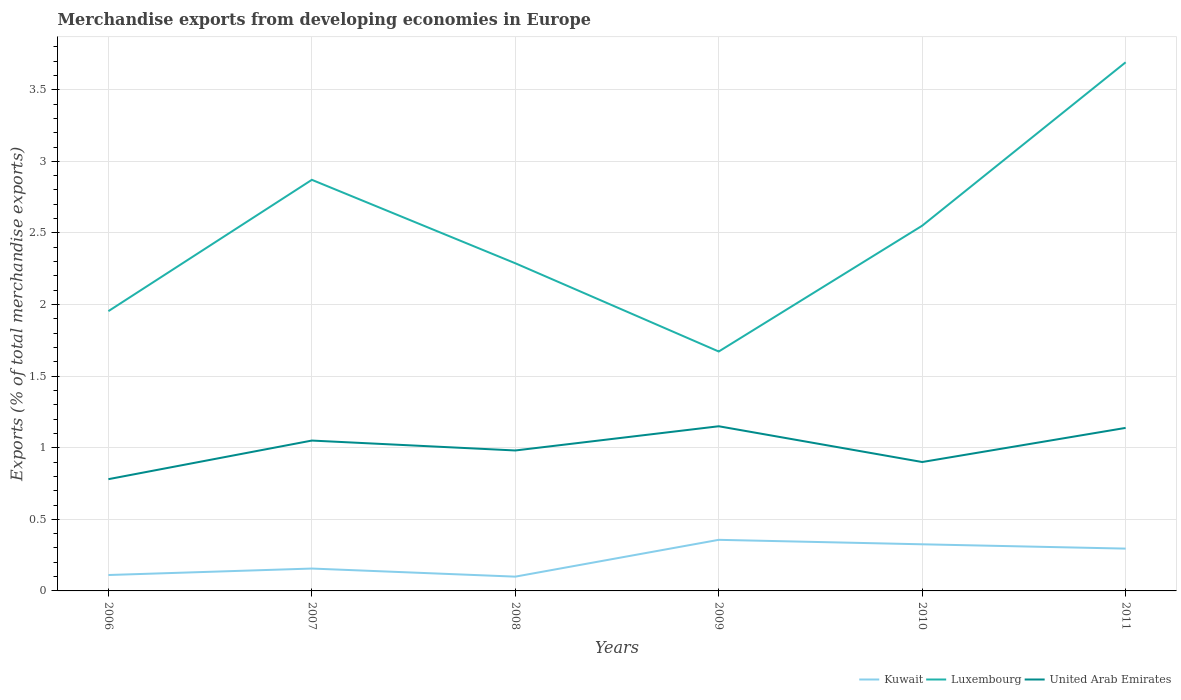Across all years, what is the maximum percentage of total merchandise exports in Kuwait?
Offer a very short reply. 0.1. What is the total percentage of total merchandise exports in Kuwait in the graph?
Provide a short and direct response. -0.05. What is the difference between the highest and the second highest percentage of total merchandise exports in Luxembourg?
Give a very brief answer. 2.02. Is the percentage of total merchandise exports in United Arab Emirates strictly greater than the percentage of total merchandise exports in Kuwait over the years?
Your answer should be compact. No. How many lines are there?
Give a very brief answer. 3. Are the values on the major ticks of Y-axis written in scientific E-notation?
Your response must be concise. No. Does the graph contain any zero values?
Your response must be concise. No. Does the graph contain grids?
Your answer should be compact. Yes. Where does the legend appear in the graph?
Give a very brief answer. Bottom right. What is the title of the graph?
Your answer should be very brief. Merchandise exports from developing economies in Europe. What is the label or title of the X-axis?
Your response must be concise. Years. What is the label or title of the Y-axis?
Your answer should be very brief. Exports (% of total merchandise exports). What is the Exports (% of total merchandise exports) of Kuwait in 2006?
Ensure brevity in your answer.  0.11. What is the Exports (% of total merchandise exports) in Luxembourg in 2006?
Give a very brief answer. 1.95. What is the Exports (% of total merchandise exports) of United Arab Emirates in 2006?
Make the answer very short. 0.78. What is the Exports (% of total merchandise exports) in Kuwait in 2007?
Provide a short and direct response. 0.16. What is the Exports (% of total merchandise exports) in Luxembourg in 2007?
Your answer should be compact. 2.87. What is the Exports (% of total merchandise exports) in United Arab Emirates in 2007?
Offer a terse response. 1.05. What is the Exports (% of total merchandise exports) in Kuwait in 2008?
Keep it short and to the point. 0.1. What is the Exports (% of total merchandise exports) in Luxembourg in 2008?
Your response must be concise. 2.29. What is the Exports (% of total merchandise exports) of United Arab Emirates in 2008?
Provide a succinct answer. 0.98. What is the Exports (% of total merchandise exports) of Kuwait in 2009?
Give a very brief answer. 0.36. What is the Exports (% of total merchandise exports) of Luxembourg in 2009?
Offer a terse response. 1.67. What is the Exports (% of total merchandise exports) of United Arab Emirates in 2009?
Provide a short and direct response. 1.15. What is the Exports (% of total merchandise exports) in Kuwait in 2010?
Provide a succinct answer. 0.33. What is the Exports (% of total merchandise exports) of Luxembourg in 2010?
Keep it short and to the point. 2.55. What is the Exports (% of total merchandise exports) of United Arab Emirates in 2010?
Provide a succinct answer. 0.9. What is the Exports (% of total merchandise exports) in Kuwait in 2011?
Your answer should be compact. 0.3. What is the Exports (% of total merchandise exports) in Luxembourg in 2011?
Provide a succinct answer. 3.69. What is the Exports (% of total merchandise exports) of United Arab Emirates in 2011?
Keep it short and to the point. 1.14. Across all years, what is the maximum Exports (% of total merchandise exports) of Kuwait?
Give a very brief answer. 0.36. Across all years, what is the maximum Exports (% of total merchandise exports) in Luxembourg?
Offer a very short reply. 3.69. Across all years, what is the maximum Exports (% of total merchandise exports) of United Arab Emirates?
Provide a short and direct response. 1.15. Across all years, what is the minimum Exports (% of total merchandise exports) in Kuwait?
Your response must be concise. 0.1. Across all years, what is the minimum Exports (% of total merchandise exports) in Luxembourg?
Provide a short and direct response. 1.67. Across all years, what is the minimum Exports (% of total merchandise exports) in United Arab Emirates?
Ensure brevity in your answer.  0.78. What is the total Exports (% of total merchandise exports) of Kuwait in the graph?
Offer a terse response. 1.34. What is the total Exports (% of total merchandise exports) of Luxembourg in the graph?
Make the answer very short. 15.03. What is the total Exports (% of total merchandise exports) of United Arab Emirates in the graph?
Provide a succinct answer. 6. What is the difference between the Exports (% of total merchandise exports) in Kuwait in 2006 and that in 2007?
Offer a terse response. -0.05. What is the difference between the Exports (% of total merchandise exports) in Luxembourg in 2006 and that in 2007?
Give a very brief answer. -0.92. What is the difference between the Exports (% of total merchandise exports) in United Arab Emirates in 2006 and that in 2007?
Make the answer very short. -0.27. What is the difference between the Exports (% of total merchandise exports) in Kuwait in 2006 and that in 2008?
Provide a short and direct response. 0.01. What is the difference between the Exports (% of total merchandise exports) of Luxembourg in 2006 and that in 2008?
Ensure brevity in your answer.  -0.33. What is the difference between the Exports (% of total merchandise exports) of United Arab Emirates in 2006 and that in 2008?
Your answer should be compact. -0.2. What is the difference between the Exports (% of total merchandise exports) of Kuwait in 2006 and that in 2009?
Keep it short and to the point. -0.25. What is the difference between the Exports (% of total merchandise exports) in Luxembourg in 2006 and that in 2009?
Your answer should be compact. 0.28. What is the difference between the Exports (% of total merchandise exports) of United Arab Emirates in 2006 and that in 2009?
Provide a short and direct response. -0.37. What is the difference between the Exports (% of total merchandise exports) of Kuwait in 2006 and that in 2010?
Ensure brevity in your answer.  -0.21. What is the difference between the Exports (% of total merchandise exports) in Luxembourg in 2006 and that in 2010?
Offer a very short reply. -0.6. What is the difference between the Exports (% of total merchandise exports) in United Arab Emirates in 2006 and that in 2010?
Your response must be concise. -0.12. What is the difference between the Exports (% of total merchandise exports) of Kuwait in 2006 and that in 2011?
Your answer should be very brief. -0.18. What is the difference between the Exports (% of total merchandise exports) in Luxembourg in 2006 and that in 2011?
Ensure brevity in your answer.  -1.74. What is the difference between the Exports (% of total merchandise exports) in United Arab Emirates in 2006 and that in 2011?
Offer a very short reply. -0.36. What is the difference between the Exports (% of total merchandise exports) of Kuwait in 2007 and that in 2008?
Offer a terse response. 0.06. What is the difference between the Exports (% of total merchandise exports) of Luxembourg in 2007 and that in 2008?
Your response must be concise. 0.58. What is the difference between the Exports (% of total merchandise exports) in United Arab Emirates in 2007 and that in 2008?
Your answer should be compact. 0.07. What is the difference between the Exports (% of total merchandise exports) of Kuwait in 2007 and that in 2009?
Ensure brevity in your answer.  -0.2. What is the difference between the Exports (% of total merchandise exports) of Luxembourg in 2007 and that in 2009?
Give a very brief answer. 1.2. What is the difference between the Exports (% of total merchandise exports) of United Arab Emirates in 2007 and that in 2009?
Provide a short and direct response. -0.1. What is the difference between the Exports (% of total merchandise exports) of Kuwait in 2007 and that in 2010?
Ensure brevity in your answer.  -0.17. What is the difference between the Exports (% of total merchandise exports) of Luxembourg in 2007 and that in 2010?
Your answer should be very brief. 0.32. What is the difference between the Exports (% of total merchandise exports) of United Arab Emirates in 2007 and that in 2010?
Your answer should be compact. 0.15. What is the difference between the Exports (% of total merchandise exports) in Kuwait in 2007 and that in 2011?
Provide a short and direct response. -0.14. What is the difference between the Exports (% of total merchandise exports) in Luxembourg in 2007 and that in 2011?
Make the answer very short. -0.82. What is the difference between the Exports (% of total merchandise exports) of United Arab Emirates in 2007 and that in 2011?
Your answer should be compact. -0.09. What is the difference between the Exports (% of total merchandise exports) of Kuwait in 2008 and that in 2009?
Make the answer very short. -0.26. What is the difference between the Exports (% of total merchandise exports) of Luxembourg in 2008 and that in 2009?
Your response must be concise. 0.62. What is the difference between the Exports (% of total merchandise exports) in United Arab Emirates in 2008 and that in 2009?
Give a very brief answer. -0.17. What is the difference between the Exports (% of total merchandise exports) of Kuwait in 2008 and that in 2010?
Offer a terse response. -0.23. What is the difference between the Exports (% of total merchandise exports) in Luxembourg in 2008 and that in 2010?
Your answer should be compact. -0.26. What is the difference between the Exports (% of total merchandise exports) in United Arab Emirates in 2008 and that in 2010?
Give a very brief answer. 0.08. What is the difference between the Exports (% of total merchandise exports) of Kuwait in 2008 and that in 2011?
Offer a terse response. -0.2. What is the difference between the Exports (% of total merchandise exports) of Luxembourg in 2008 and that in 2011?
Make the answer very short. -1.4. What is the difference between the Exports (% of total merchandise exports) in United Arab Emirates in 2008 and that in 2011?
Your answer should be compact. -0.16. What is the difference between the Exports (% of total merchandise exports) in Kuwait in 2009 and that in 2010?
Your answer should be very brief. 0.03. What is the difference between the Exports (% of total merchandise exports) in Luxembourg in 2009 and that in 2010?
Give a very brief answer. -0.88. What is the difference between the Exports (% of total merchandise exports) of United Arab Emirates in 2009 and that in 2010?
Offer a terse response. 0.25. What is the difference between the Exports (% of total merchandise exports) in Kuwait in 2009 and that in 2011?
Offer a very short reply. 0.06. What is the difference between the Exports (% of total merchandise exports) of Luxembourg in 2009 and that in 2011?
Your answer should be very brief. -2.02. What is the difference between the Exports (% of total merchandise exports) in United Arab Emirates in 2009 and that in 2011?
Make the answer very short. 0.01. What is the difference between the Exports (% of total merchandise exports) in Kuwait in 2010 and that in 2011?
Give a very brief answer. 0.03. What is the difference between the Exports (% of total merchandise exports) of Luxembourg in 2010 and that in 2011?
Keep it short and to the point. -1.14. What is the difference between the Exports (% of total merchandise exports) in United Arab Emirates in 2010 and that in 2011?
Offer a very short reply. -0.24. What is the difference between the Exports (% of total merchandise exports) in Kuwait in 2006 and the Exports (% of total merchandise exports) in Luxembourg in 2007?
Your response must be concise. -2.76. What is the difference between the Exports (% of total merchandise exports) of Kuwait in 2006 and the Exports (% of total merchandise exports) of United Arab Emirates in 2007?
Offer a very short reply. -0.94. What is the difference between the Exports (% of total merchandise exports) of Luxembourg in 2006 and the Exports (% of total merchandise exports) of United Arab Emirates in 2007?
Your answer should be very brief. 0.9. What is the difference between the Exports (% of total merchandise exports) in Kuwait in 2006 and the Exports (% of total merchandise exports) in Luxembourg in 2008?
Give a very brief answer. -2.18. What is the difference between the Exports (% of total merchandise exports) of Kuwait in 2006 and the Exports (% of total merchandise exports) of United Arab Emirates in 2008?
Ensure brevity in your answer.  -0.87. What is the difference between the Exports (% of total merchandise exports) in Kuwait in 2006 and the Exports (% of total merchandise exports) in Luxembourg in 2009?
Your answer should be very brief. -1.56. What is the difference between the Exports (% of total merchandise exports) of Kuwait in 2006 and the Exports (% of total merchandise exports) of United Arab Emirates in 2009?
Provide a succinct answer. -1.04. What is the difference between the Exports (% of total merchandise exports) of Luxembourg in 2006 and the Exports (% of total merchandise exports) of United Arab Emirates in 2009?
Provide a succinct answer. 0.8. What is the difference between the Exports (% of total merchandise exports) in Kuwait in 2006 and the Exports (% of total merchandise exports) in Luxembourg in 2010?
Provide a succinct answer. -2.44. What is the difference between the Exports (% of total merchandise exports) of Kuwait in 2006 and the Exports (% of total merchandise exports) of United Arab Emirates in 2010?
Offer a very short reply. -0.79. What is the difference between the Exports (% of total merchandise exports) in Luxembourg in 2006 and the Exports (% of total merchandise exports) in United Arab Emirates in 2010?
Provide a short and direct response. 1.05. What is the difference between the Exports (% of total merchandise exports) of Kuwait in 2006 and the Exports (% of total merchandise exports) of Luxembourg in 2011?
Your answer should be compact. -3.58. What is the difference between the Exports (% of total merchandise exports) of Kuwait in 2006 and the Exports (% of total merchandise exports) of United Arab Emirates in 2011?
Offer a very short reply. -1.03. What is the difference between the Exports (% of total merchandise exports) in Luxembourg in 2006 and the Exports (% of total merchandise exports) in United Arab Emirates in 2011?
Offer a very short reply. 0.82. What is the difference between the Exports (% of total merchandise exports) in Kuwait in 2007 and the Exports (% of total merchandise exports) in Luxembourg in 2008?
Ensure brevity in your answer.  -2.13. What is the difference between the Exports (% of total merchandise exports) of Kuwait in 2007 and the Exports (% of total merchandise exports) of United Arab Emirates in 2008?
Your response must be concise. -0.82. What is the difference between the Exports (% of total merchandise exports) of Luxembourg in 2007 and the Exports (% of total merchandise exports) of United Arab Emirates in 2008?
Provide a succinct answer. 1.89. What is the difference between the Exports (% of total merchandise exports) of Kuwait in 2007 and the Exports (% of total merchandise exports) of Luxembourg in 2009?
Your response must be concise. -1.52. What is the difference between the Exports (% of total merchandise exports) in Kuwait in 2007 and the Exports (% of total merchandise exports) in United Arab Emirates in 2009?
Your answer should be very brief. -0.99. What is the difference between the Exports (% of total merchandise exports) in Luxembourg in 2007 and the Exports (% of total merchandise exports) in United Arab Emirates in 2009?
Your response must be concise. 1.72. What is the difference between the Exports (% of total merchandise exports) in Kuwait in 2007 and the Exports (% of total merchandise exports) in Luxembourg in 2010?
Your answer should be very brief. -2.39. What is the difference between the Exports (% of total merchandise exports) of Kuwait in 2007 and the Exports (% of total merchandise exports) of United Arab Emirates in 2010?
Keep it short and to the point. -0.74. What is the difference between the Exports (% of total merchandise exports) in Luxembourg in 2007 and the Exports (% of total merchandise exports) in United Arab Emirates in 2010?
Make the answer very short. 1.97. What is the difference between the Exports (% of total merchandise exports) of Kuwait in 2007 and the Exports (% of total merchandise exports) of Luxembourg in 2011?
Your answer should be very brief. -3.54. What is the difference between the Exports (% of total merchandise exports) in Kuwait in 2007 and the Exports (% of total merchandise exports) in United Arab Emirates in 2011?
Your response must be concise. -0.98. What is the difference between the Exports (% of total merchandise exports) of Luxembourg in 2007 and the Exports (% of total merchandise exports) of United Arab Emirates in 2011?
Provide a short and direct response. 1.73. What is the difference between the Exports (% of total merchandise exports) of Kuwait in 2008 and the Exports (% of total merchandise exports) of Luxembourg in 2009?
Your answer should be compact. -1.57. What is the difference between the Exports (% of total merchandise exports) in Kuwait in 2008 and the Exports (% of total merchandise exports) in United Arab Emirates in 2009?
Keep it short and to the point. -1.05. What is the difference between the Exports (% of total merchandise exports) in Luxembourg in 2008 and the Exports (% of total merchandise exports) in United Arab Emirates in 2009?
Ensure brevity in your answer.  1.14. What is the difference between the Exports (% of total merchandise exports) in Kuwait in 2008 and the Exports (% of total merchandise exports) in Luxembourg in 2010?
Provide a short and direct response. -2.45. What is the difference between the Exports (% of total merchandise exports) in Kuwait in 2008 and the Exports (% of total merchandise exports) in United Arab Emirates in 2010?
Your answer should be very brief. -0.8. What is the difference between the Exports (% of total merchandise exports) of Luxembourg in 2008 and the Exports (% of total merchandise exports) of United Arab Emirates in 2010?
Your response must be concise. 1.39. What is the difference between the Exports (% of total merchandise exports) in Kuwait in 2008 and the Exports (% of total merchandise exports) in Luxembourg in 2011?
Your answer should be compact. -3.59. What is the difference between the Exports (% of total merchandise exports) of Kuwait in 2008 and the Exports (% of total merchandise exports) of United Arab Emirates in 2011?
Provide a succinct answer. -1.04. What is the difference between the Exports (% of total merchandise exports) in Luxembourg in 2008 and the Exports (% of total merchandise exports) in United Arab Emirates in 2011?
Offer a terse response. 1.15. What is the difference between the Exports (% of total merchandise exports) in Kuwait in 2009 and the Exports (% of total merchandise exports) in Luxembourg in 2010?
Offer a terse response. -2.19. What is the difference between the Exports (% of total merchandise exports) in Kuwait in 2009 and the Exports (% of total merchandise exports) in United Arab Emirates in 2010?
Provide a succinct answer. -0.54. What is the difference between the Exports (% of total merchandise exports) of Luxembourg in 2009 and the Exports (% of total merchandise exports) of United Arab Emirates in 2010?
Provide a succinct answer. 0.77. What is the difference between the Exports (% of total merchandise exports) in Kuwait in 2009 and the Exports (% of total merchandise exports) in Luxembourg in 2011?
Ensure brevity in your answer.  -3.33. What is the difference between the Exports (% of total merchandise exports) in Kuwait in 2009 and the Exports (% of total merchandise exports) in United Arab Emirates in 2011?
Provide a short and direct response. -0.78. What is the difference between the Exports (% of total merchandise exports) in Luxembourg in 2009 and the Exports (% of total merchandise exports) in United Arab Emirates in 2011?
Your answer should be very brief. 0.53. What is the difference between the Exports (% of total merchandise exports) in Kuwait in 2010 and the Exports (% of total merchandise exports) in Luxembourg in 2011?
Give a very brief answer. -3.37. What is the difference between the Exports (% of total merchandise exports) in Kuwait in 2010 and the Exports (% of total merchandise exports) in United Arab Emirates in 2011?
Keep it short and to the point. -0.81. What is the difference between the Exports (% of total merchandise exports) of Luxembourg in 2010 and the Exports (% of total merchandise exports) of United Arab Emirates in 2011?
Ensure brevity in your answer.  1.41. What is the average Exports (% of total merchandise exports) of Kuwait per year?
Your answer should be very brief. 0.22. What is the average Exports (% of total merchandise exports) in Luxembourg per year?
Provide a short and direct response. 2.5. What is the average Exports (% of total merchandise exports) in United Arab Emirates per year?
Provide a short and direct response. 1. In the year 2006, what is the difference between the Exports (% of total merchandise exports) in Kuwait and Exports (% of total merchandise exports) in Luxembourg?
Provide a succinct answer. -1.84. In the year 2006, what is the difference between the Exports (% of total merchandise exports) of Kuwait and Exports (% of total merchandise exports) of United Arab Emirates?
Provide a succinct answer. -0.67. In the year 2006, what is the difference between the Exports (% of total merchandise exports) in Luxembourg and Exports (% of total merchandise exports) in United Arab Emirates?
Your answer should be compact. 1.17. In the year 2007, what is the difference between the Exports (% of total merchandise exports) in Kuwait and Exports (% of total merchandise exports) in Luxembourg?
Make the answer very short. -2.71. In the year 2007, what is the difference between the Exports (% of total merchandise exports) of Kuwait and Exports (% of total merchandise exports) of United Arab Emirates?
Your answer should be very brief. -0.89. In the year 2007, what is the difference between the Exports (% of total merchandise exports) in Luxembourg and Exports (% of total merchandise exports) in United Arab Emirates?
Your answer should be very brief. 1.82. In the year 2008, what is the difference between the Exports (% of total merchandise exports) in Kuwait and Exports (% of total merchandise exports) in Luxembourg?
Your answer should be very brief. -2.19. In the year 2008, what is the difference between the Exports (% of total merchandise exports) in Kuwait and Exports (% of total merchandise exports) in United Arab Emirates?
Offer a very short reply. -0.88. In the year 2008, what is the difference between the Exports (% of total merchandise exports) of Luxembourg and Exports (% of total merchandise exports) of United Arab Emirates?
Make the answer very short. 1.31. In the year 2009, what is the difference between the Exports (% of total merchandise exports) in Kuwait and Exports (% of total merchandise exports) in Luxembourg?
Make the answer very short. -1.32. In the year 2009, what is the difference between the Exports (% of total merchandise exports) of Kuwait and Exports (% of total merchandise exports) of United Arab Emirates?
Keep it short and to the point. -0.79. In the year 2009, what is the difference between the Exports (% of total merchandise exports) of Luxembourg and Exports (% of total merchandise exports) of United Arab Emirates?
Provide a succinct answer. 0.52. In the year 2010, what is the difference between the Exports (% of total merchandise exports) of Kuwait and Exports (% of total merchandise exports) of Luxembourg?
Provide a short and direct response. -2.22. In the year 2010, what is the difference between the Exports (% of total merchandise exports) in Kuwait and Exports (% of total merchandise exports) in United Arab Emirates?
Provide a succinct answer. -0.57. In the year 2010, what is the difference between the Exports (% of total merchandise exports) in Luxembourg and Exports (% of total merchandise exports) in United Arab Emirates?
Offer a terse response. 1.65. In the year 2011, what is the difference between the Exports (% of total merchandise exports) in Kuwait and Exports (% of total merchandise exports) in Luxembourg?
Provide a short and direct response. -3.4. In the year 2011, what is the difference between the Exports (% of total merchandise exports) of Kuwait and Exports (% of total merchandise exports) of United Arab Emirates?
Offer a very short reply. -0.84. In the year 2011, what is the difference between the Exports (% of total merchandise exports) of Luxembourg and Exports (% of total merchandise exports) of United Arab Emirates?
Give a very brief answer. 2.55. What is the ratio of the Exports (% of total merchandise exports) of Kuwait in 2006 to that in 2007?
Keep it short and to the point. 0.71. What is the ratio of the Exports (% of total merchandise exports) of Luxembourg in 2006 to that in 2007?
Offer a terse response. 0.68. What is the ratio of the Exports (% of total merchandise exports) in United Arab Emirates in 2006 to that in 2007?
Provide a short and direct response. 0.74. What is the ratio of the Exports (% of total merchandise exports) in Kuwait in 2006 to that in 2008?
Provide a succinct answer. 1.11. What is the ratio of the Exports (% of total merchandise exports) of Luxembourg in 2006 to that in 2008?
Offer a terse response. 0.85. What is the ratio of the Exports (% of total merchandise exports) in United Arab Emirates in 2006 to that in 2008?
Your answer should be compact. 0.8. What is the ratio of the Exports (% of total merchandise exports) in Kuwait in 2006 to that in 2009?
Keep it short and to the point. 0.31. What is the ratio of the Exports (% of total merchandise exports) of Luxembourg in 2006 to that in 2009?
Provide a succinct answer. 1.17. What is the ratio of the Exports (% of total merchandise exports) in United Arab Emirates in 2006 to that in 2009?
Give a very brief answer. 0.68. What is the ratio of the Exports (% of total merchandise exports) of Kuwait in 2006 to that in 2010?
Offer a terse response. 0.34. What is the ratio of the Exports (% of total merchandise exports) in Luxembourg in 2006 to that in 2010?
Provide a succinct answer. 0.77. What is the ratio of the Exports (% of total merchandise exports) of United Arab Emirates in 2006 to that in 2010?
Offer a very short reply. 0.87. What is the ratio of the Exports (% of total merchandise exports) of Kuwait in 2006 to that in 2011?
Keep it short and to the point. 0.38. What is the ratio of the Exports (% of total merchandise exports) in Luxembourg in 2006 to that in 2011?
Your answer should be compact. 0.53. What is the ratio of the Exports (% of total merchandise exports) in United Arab Emirates in 2006 to that in 2011?
Your answer should be very brief. 0.69. What is the ratio of the Exports (% of total merchandise exports) of Kuwait in 2007 to that in 2008?
Offer a terse response. 1.57. What is the ratio of the Exports (% of total merchandise exports) of Luxembourg in 2007 to that in 2008?
Provide a succinct answer. 1.25. What is the ratio of the Exports (% of total merchandise exports) of United Arab Emirates in 2007 to that in 2008?
Offer a terse response. 1.07. What is the ratio of the Exports (% of total merchandise exports) of Kuwait in 2007 to that in 2009?
Provide a short and direct response. 0.44. What is the ratio of the Exports (% of total merchandise exports) of Luxembourg in 2007 to that in 2009?
Your response must be concise. 1.72. What is the ratio of the Exports (% of total merchandise exports) of United Arab Emirates in 2007 to that in 2009?
Provide a short and direct response. 0.91. What is the ratio of the Exports (% of total merchandise exports) in Kuwait in 2007 to that in 2010?
Ensure brevity in your answer.  0.48. What is the ratio of the Exports (% of total merchandise exports) in Luxembourg in 2007 to that in 2010?
Your answer should be very brief. 1.13. What is the ratio of the Exports (% of total merchandise exports) of United Arab Emirates in 2007 to that in 2010?
Your answer should be compact. 1.17. What is the ratio of the Exports (% of total merchandise exports) of Kuwait in 2007 to that in 2011?
Your response must be concise. 0.53. What is the ratio of the Exports (% of total merchandise exports) in Luxembourg in 2007 to that in 2011?
Offer a very short reply. 0.78. What is the ratio of the Exports (% of total merchandise exports) in United Arab Emirates in 2007 to that in 2011?
Give a very brief answer. 0.92. What is the ratio of the Exports (% of total merchandise exports) in Kuwait in 2008 to that in 2009?
Your response must be concise. 0.28. What is the ratio of the Exports (% of total merchandise exports) in Luxembourg in 2008 to that in 2009?
Ensure brevity in your answer.  1.37. What is the ratio of the Exports (% of total merchandise exports) of United Arab Emirates in 2008 to that in 2009?
Make the answer very short. 0.85. What is the ratio of the Exports (% of total merchandise exports) in Kuwait in 2008 to that in 2010?
Keep it short and to the point. 0.31. What is the ratio of the Exports (% of total merchandise exports) of Luxembourg in 2008 to that in 2010?
Provide a short and direct response. 0.9. What is the ratio of the Exports (% of total merchandise exports) in United Arab Emirates in 2008 to that in 2010?
Your response must be concise. 1.09. What is the ratio of the Exports (% of total merchandise exports) in Kuwait in 2008 to that in 2011?
Your answer should be very brief. 0.34. What is the ratio of the Exports (% of total merchandise exports) in Luxembourg in 2008 to that in 2011?
Provide a short and direct response. 0.62. What is the ratio of the Exports (% of total merchandise exports) of United Arab Emirates in 2008 to that in 2011?
Offer a very short reply. 0.86. What is the ratio of the Exports (% of total merchandise exports) in Kuwait in 2009 to that in 2010?
Keep it short and to the point. 1.1. What is the ratio of the Exports (% of total merchandise exports) in Luxembourg in 2009 to that in 2010?
Keep it short and to the point. 0.66. What is the ratio of the Exports (% of total merchandise exports) of United Arab Emirates in 2009 to that in 2010?
Provide a succinct answer. 1.28. What is the ratio of the Exports (% of total merchandise exports) in Kuwait in 2009 to that in 2011?
Offer a terse response. 1.21. What is the ratio of the Exports (% of total merchandise exports) of Luxembourg in 2009 to that in 2011?
Your answer should be compact. 0.45. What is the ratio of the Exports (% of total merchandise exports) in United Arab Emirates in 2009 to that in 2011?
Make the answer very short. 1.01. What is the ratio of the Exports (% of total merchandise exports) of Kuwait in 2010 to that in 2011?
Keep it short and to the point. 1.1. What is the ratio of the Exports (% of total merchandise exports) in Luxembourg in 2010 to that in 2011?
Give a very brief answer. 0.69. What is the ratio of the Exports (% of total merchandise exports) in United Arab Emirates in 2010 to that in 2011?
Your answer should be very brief. 0.79. What is the difference between the highest and the second highest Exports (% of total merchandise exports) in Kuwait?
Your response must be concise. 0.03. What is the difference between the highest and the second highest Exports (% of total merchandise exports) of Luxembourg?
Your answer should be very brief. 0.82. What is the difference between the highest and the second highest Exports (% of total merchandise exports) in United Arab Emirates?
Your response must be concise. 0.01. What is the difference between the highest and the lowest Exports (% of total merchandise exports) of Kuwait?
Make the answer very short. 0.26. What is the difference between the highest and the lowest Exports (% of total merchandise exports) in Luxembourg?
Your response must be concise. 2.02. What is the difference between the highest and the lowest Exports (% of total merchandise exports) of United Arab Emirates?
Provide a short and direct response. 0.37. 